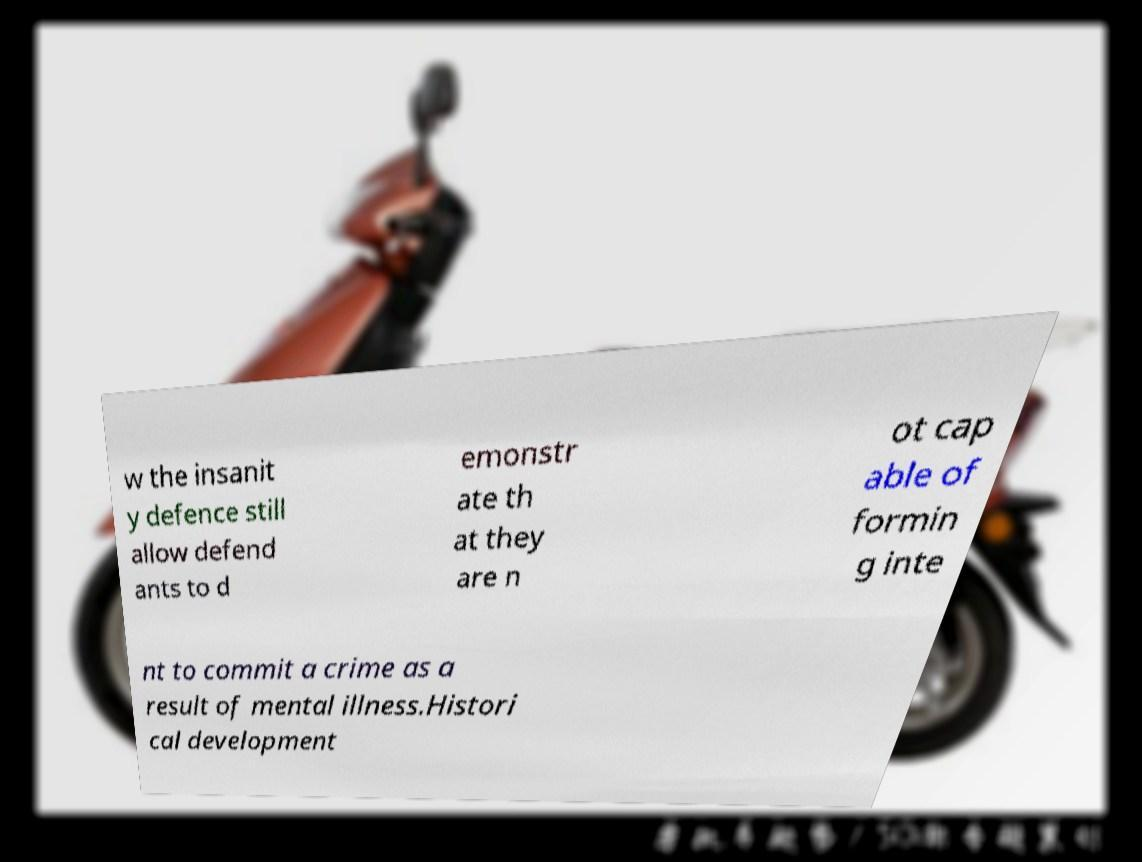There's text embedded in this image that I need extracted. Can you transcribe it verbatim? w the insanit y defence still allow defend ants to d emonstr ate th at they are n ot cap able of formin g inte nt to commit a crime as a result of mental illness.Histori cal development 